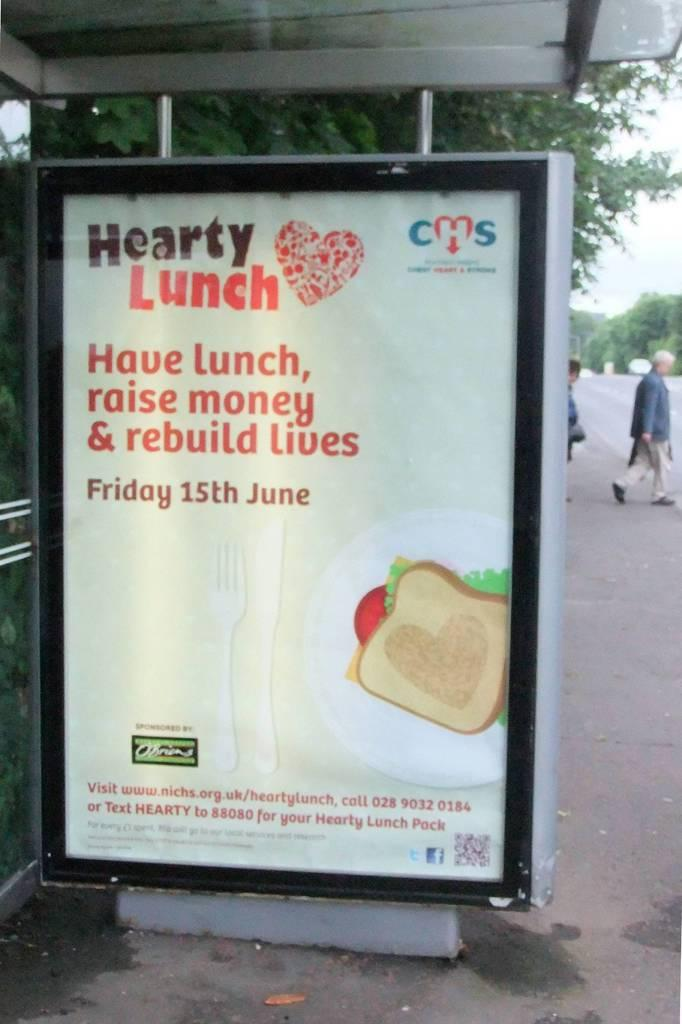Provide a one-sentence caption for the provided image. A large sign is on the sidewalk and advertises a fundraiser on June 15th. 